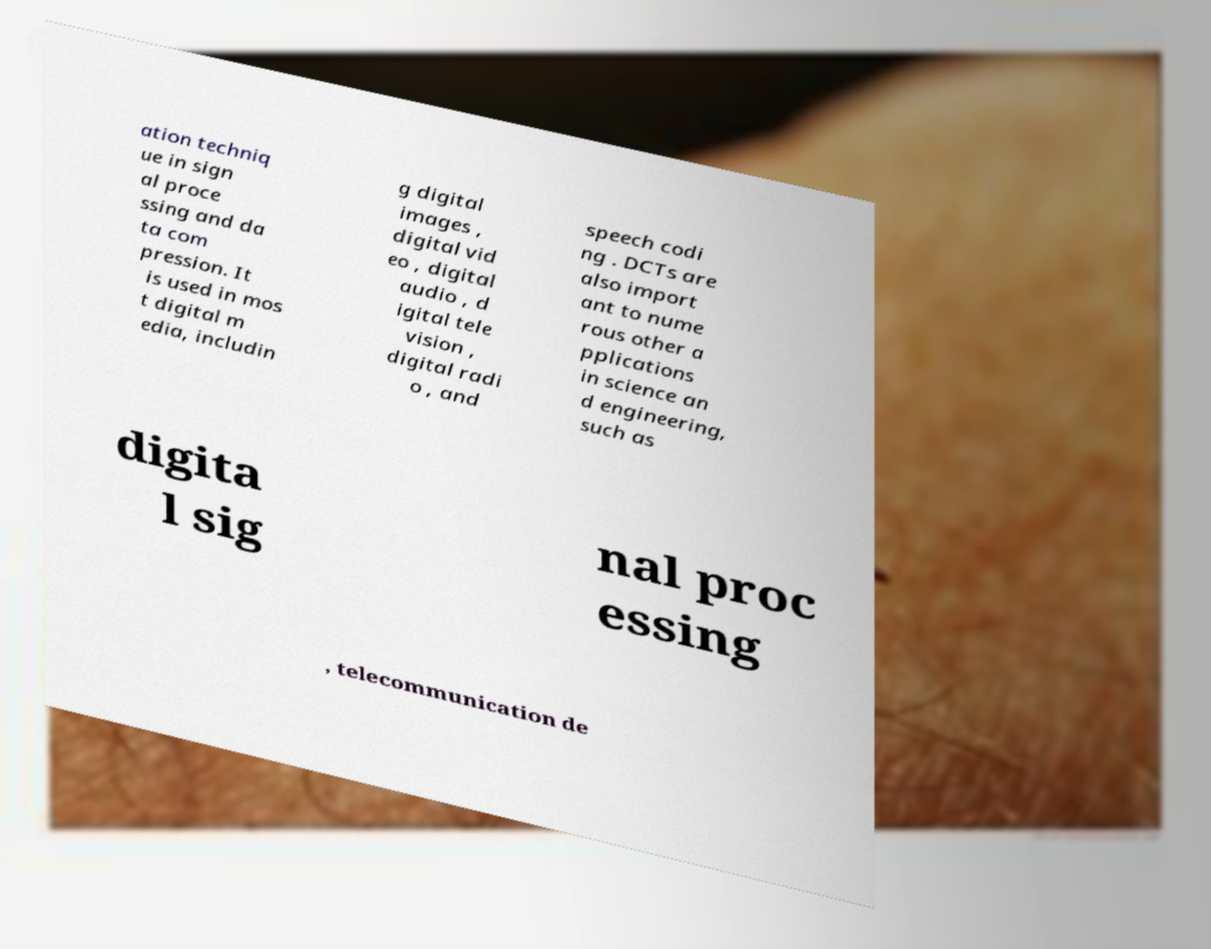Please read and relay the text visible in this image. What does it say? ation techniq ue in sign al proce ssing and da ta com pression. It is used in mos t digital m edia, includin g digital images , digital vid eo , digital audio , d igital tele vision , digital radi o , and speech codi ng . DCTs are also import ant to nume rous other a pplications in science an d engineering, such as digita l sig nal proc essing , telecommunication de 